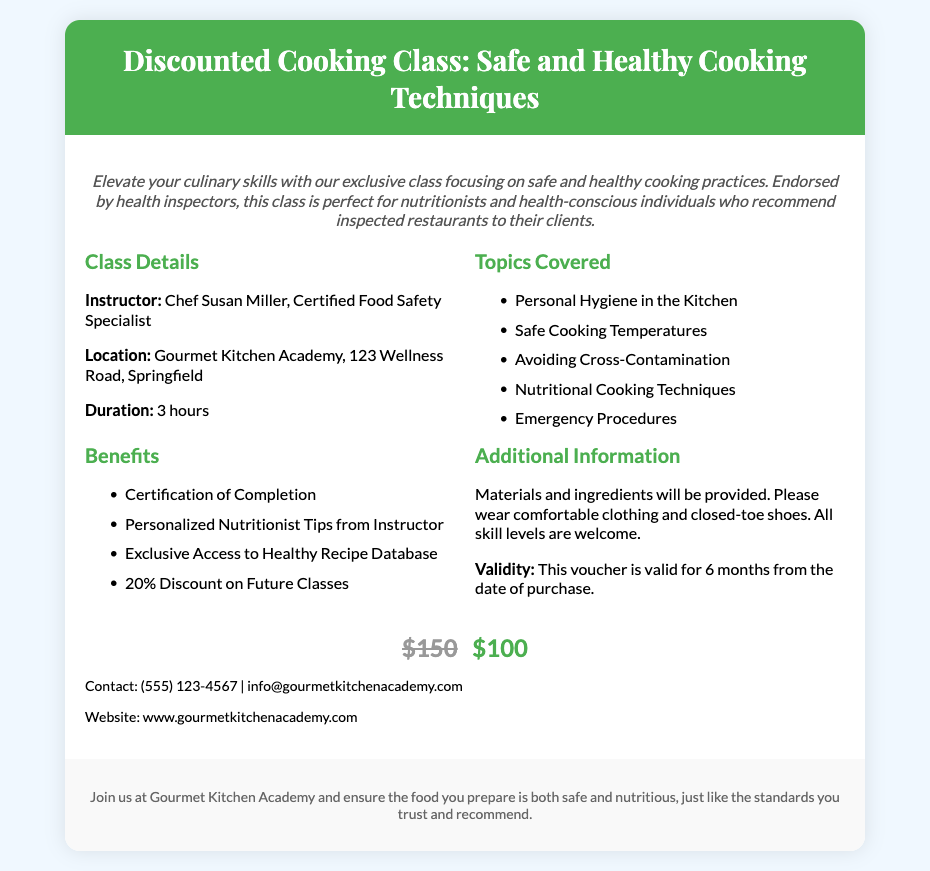What is the name of the instructor? The instructor for the cooking class is mentioned in the document as Chef Susan Miller.
Answer: Chef Susan Miller What is the location of the cooking class? The document specifies the location as Gourmet Kitchen Academy, 123 Wellness Road, Springfield.
Answer: Gourmet Kitchen Academy, 123 Wellness Road, Springfield How long is the duration of the class? The duration of the cooking class is stated in the document as 3 hours.
Answer: 3 hours What discount is offered on future classes? The document mentions a 20% discount on future classes as one of the benefits.
Answer: 20% What is the validity period of the voucher? The document indicates that the voucher is valid for 6 months from the date of purchase.
Answer: 6 months Which safety procedure is included in the topics covered? The document lists "Emergency Procedures" as one of the topics covered in the class.
Answer: Emergency Procedures What is the original price of the cooking class? The document states the original price of the cooking class as $150.
Answer: $150 What type of certification is provided upon completion? The document mentions that participants will receive a "Certification of Completion."
Answer: Certification of Completion What should participants wear to the cooking class? The document advises participants to wear comfortable clothing and closed-toe shoes.
Answer: Comfortable clothing and closed-toe shoes 